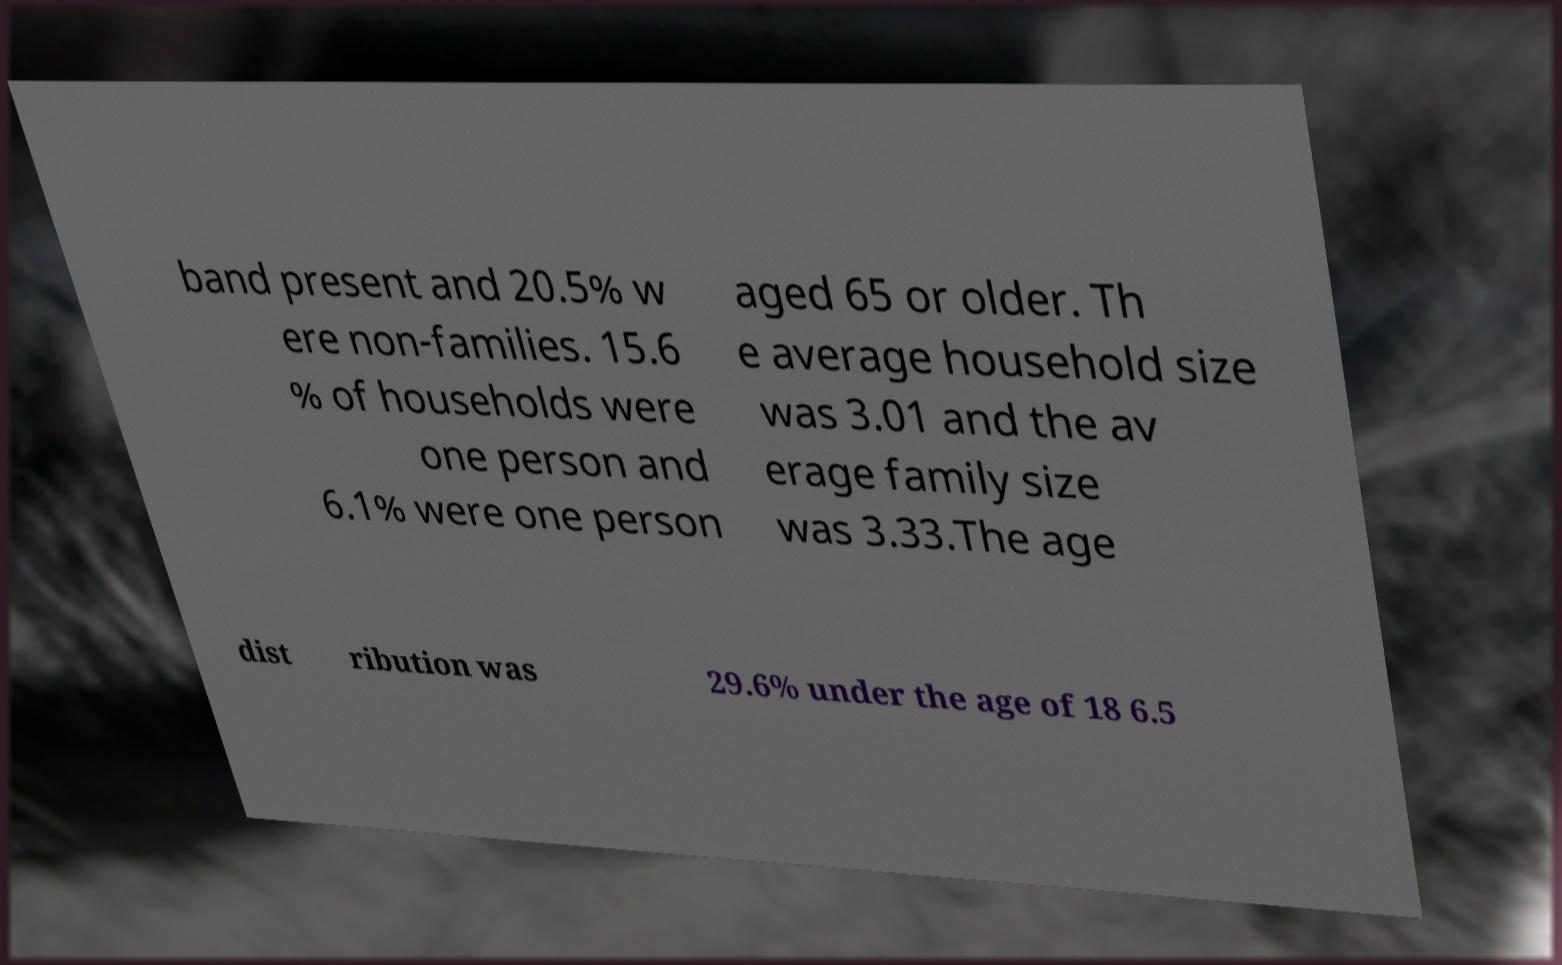Could you assist in decoding the text presented in this image and type it out clearly? band present and 20.5% w ere non-families. 15.6 % of households were one person and 6.1% were one person aged 65 or older. Th e average household size was 3.01 and the av erage family size was 3.33.The age dist ribution was 29.6% under the age of 18 6.5 